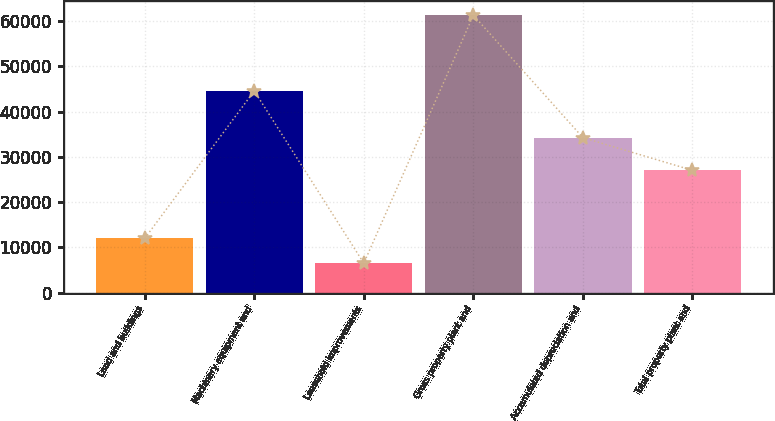Convert chart. <chart><loc_0><loc_0><loc_500><loc_500><bar_chart><fcel>Land and buildings<fcel>Machinery equipment and<fcel>Leasehold improvements<fcel>Gross property plant and<fcel>Accumulated depreciation and<fcel>Total property plant and<nl><fcel>11989.8<fcel>44543<fcel>6517<fcel>61245<fcel>34235<fcel>27010<nl></chart> 